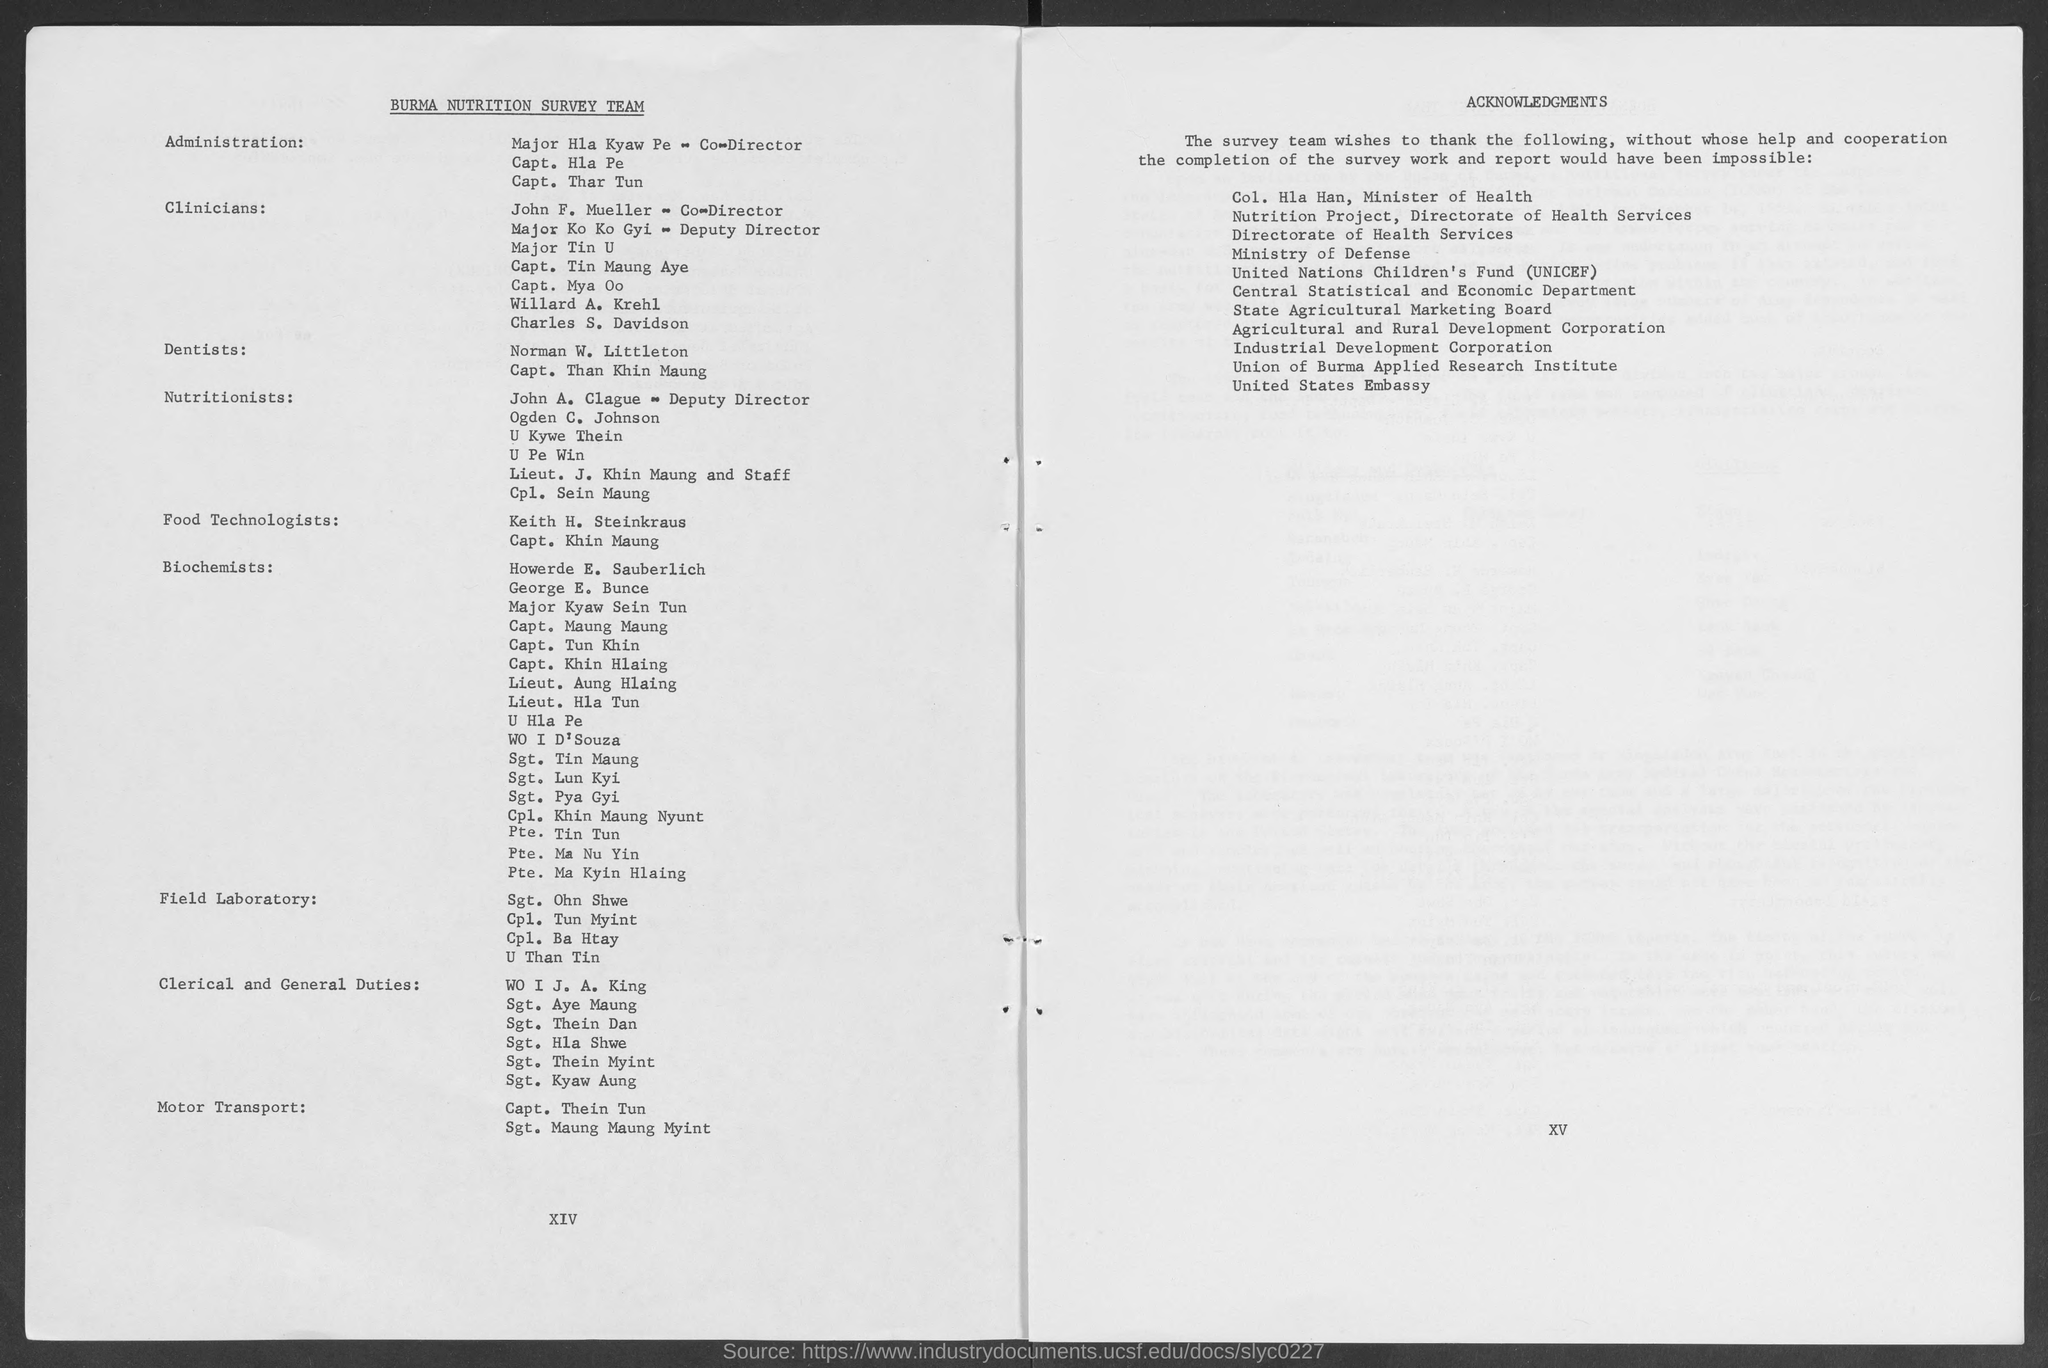What does unicef stand for ?
Your response must be concise. United nations children's fund. What is the heading at top of left page ?
Offer a terse response. Burma Nutrition Survey Team. What is the heading at top of right page ?
Your answer should be compact. Acknowledgements. 